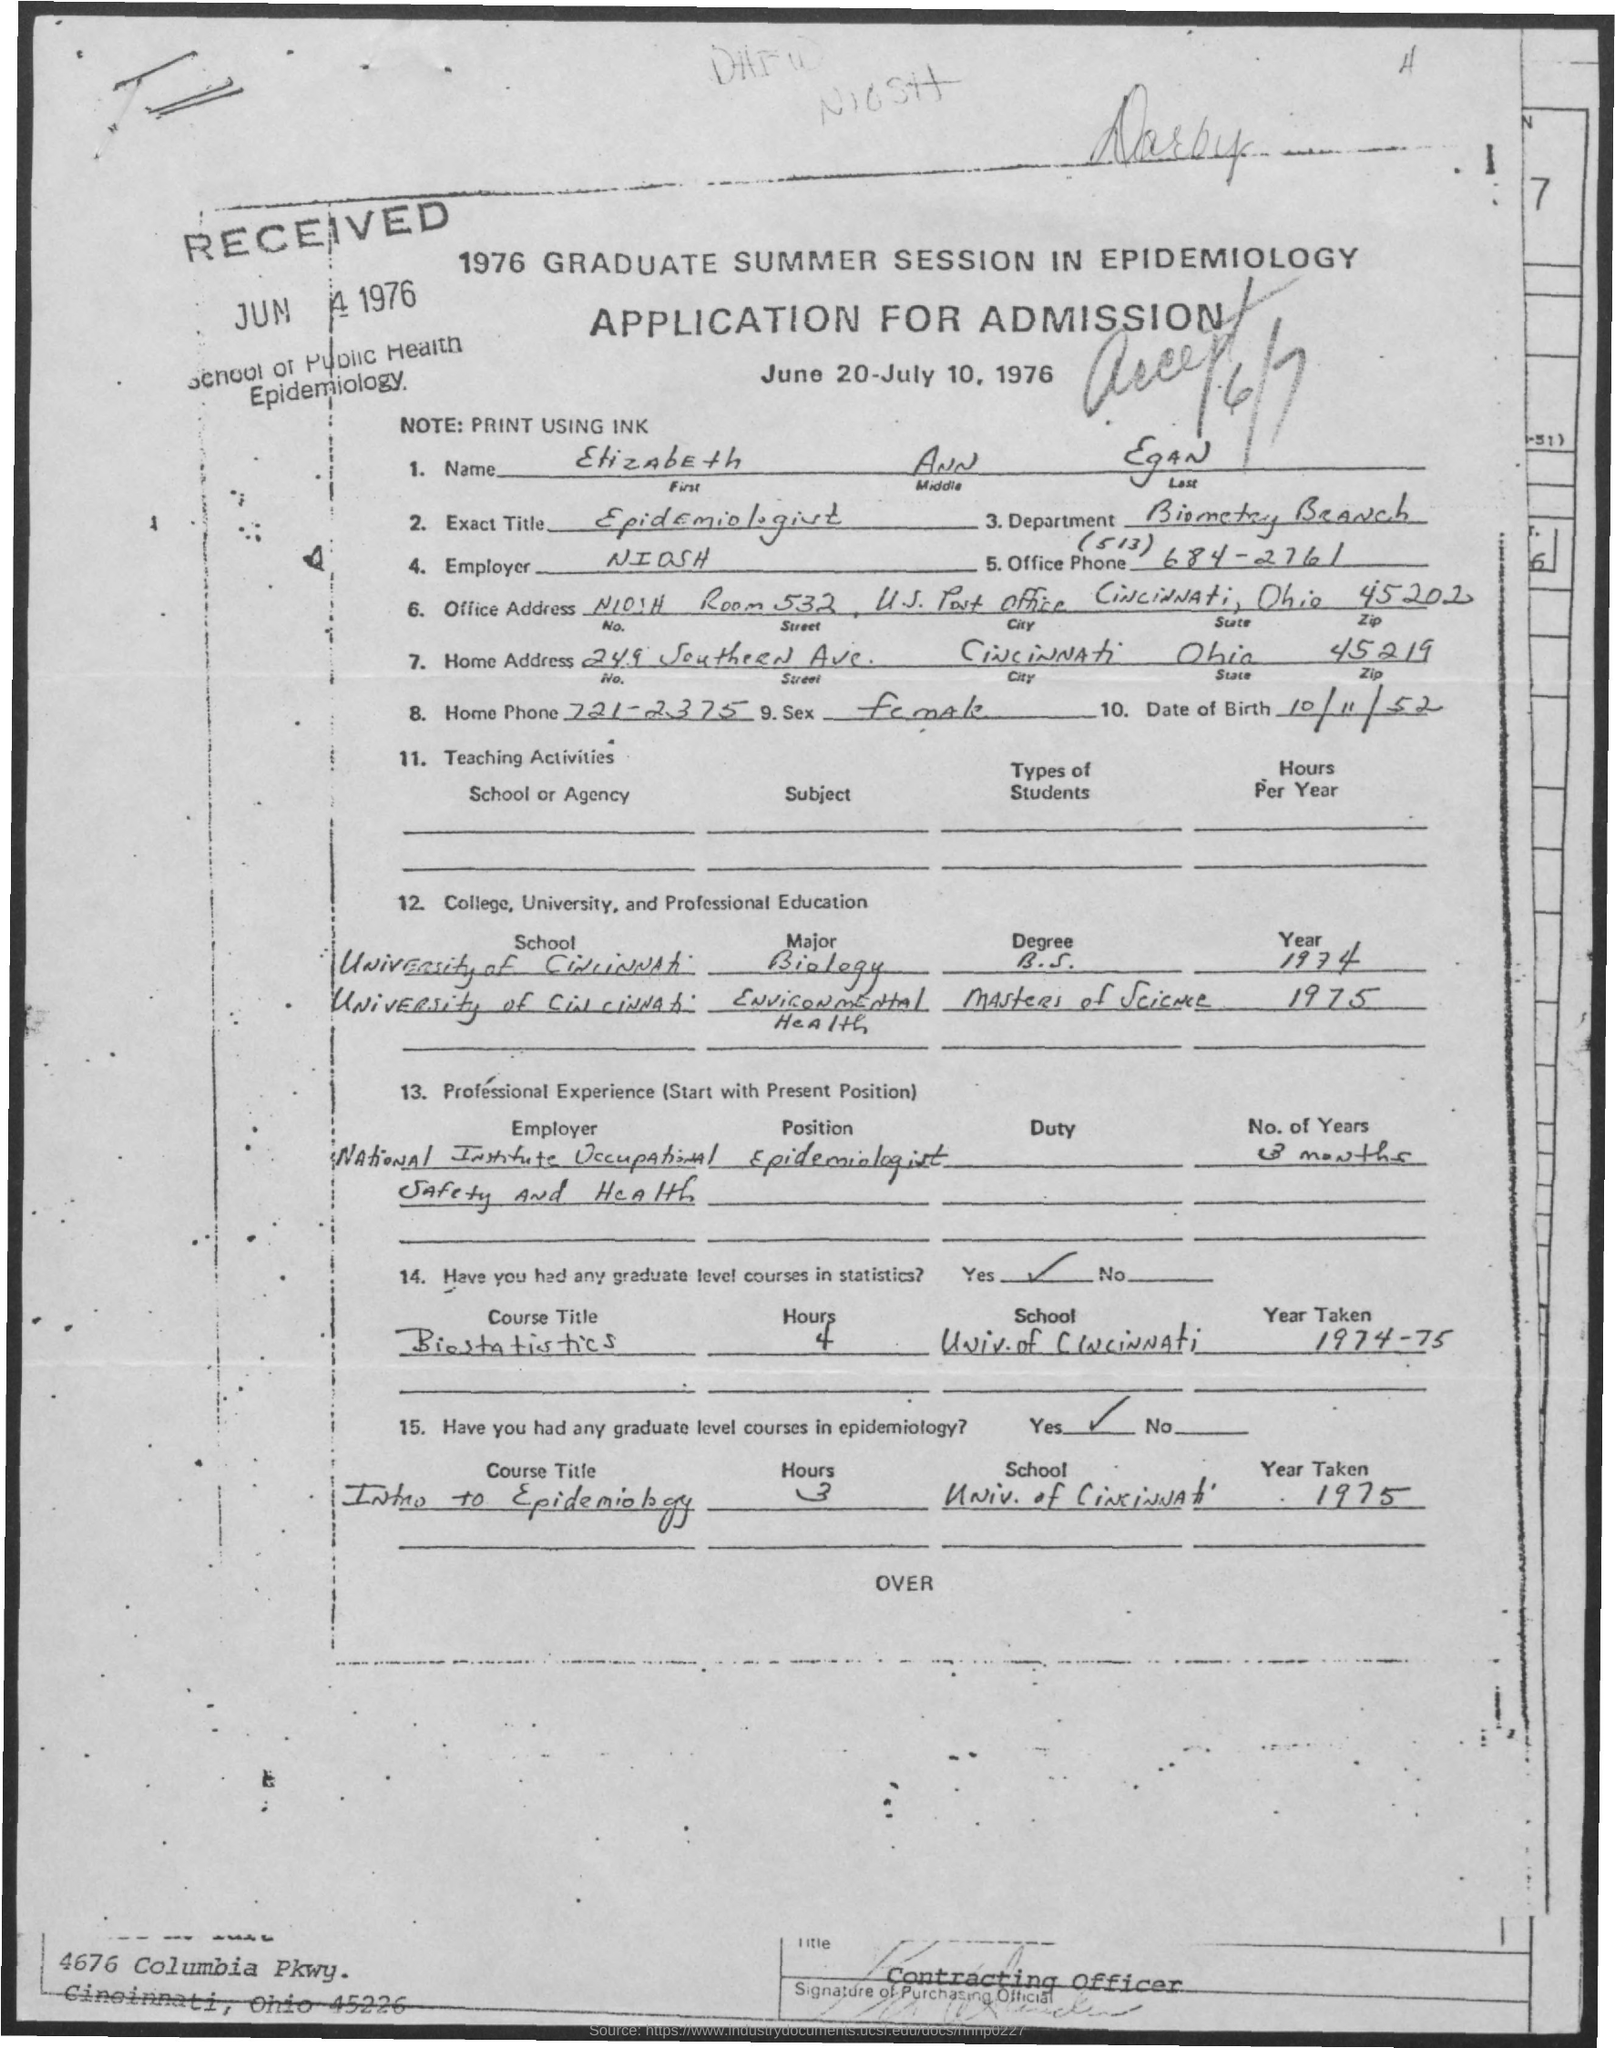What is the First Name?
Make the answer very short. Elizabeth. What is the Middle Name?
Make the answer very short. Ann. What is the Last Name?
Provide a short and direct response. Egan. What is the Exact Title?
Give a very brief answer. Epidemiologist. Which is the Department?
Keep it short and to the point. Biometry Branch. Who is the Employer?
Make the answer very short. NIOSH. Which is the City?
Offer a very short reply. Cincinnati. Which is the State?
Make the answer very short. Ohio. 